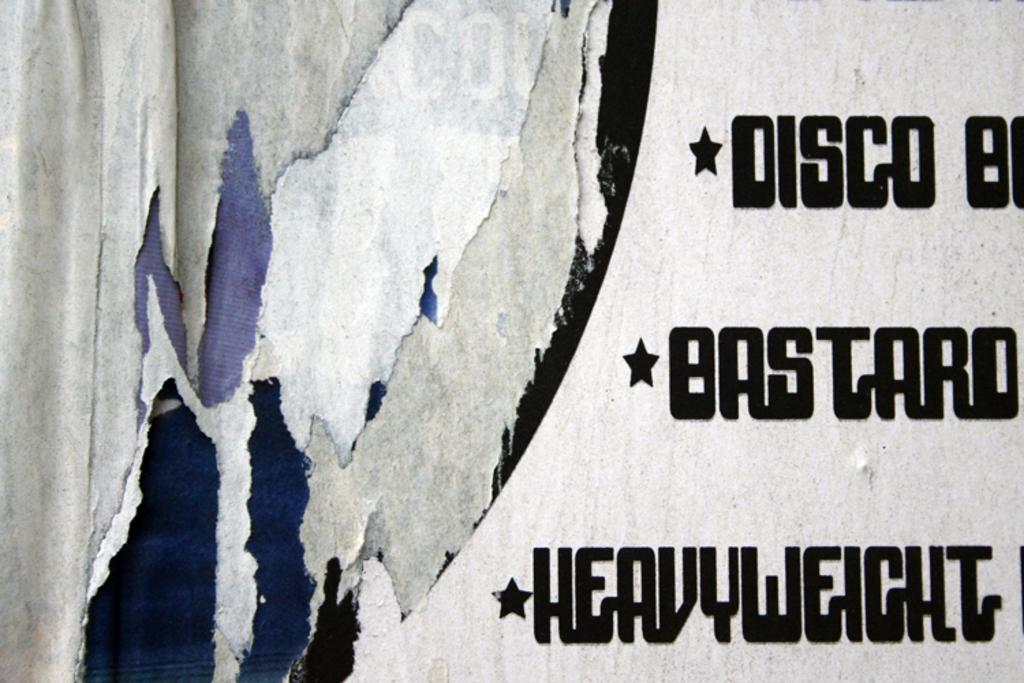<image>
Offer a succinct explanation of the picture presented. A sign with whites and blues overlaid on one side has text including heavyweight on the other. 